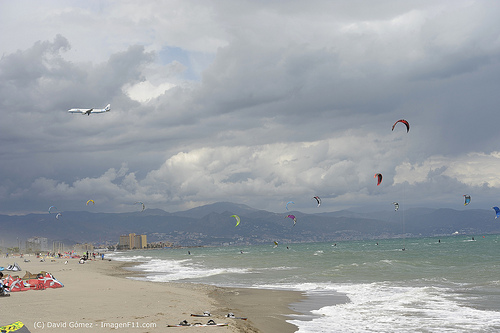Please provide the bounding box coordinate of the region this sentence describes: part of a beach. The bounding box coordinates for the region described as 'part of a beach' are [0.18, 0.73, 0.23, 0.77]. 